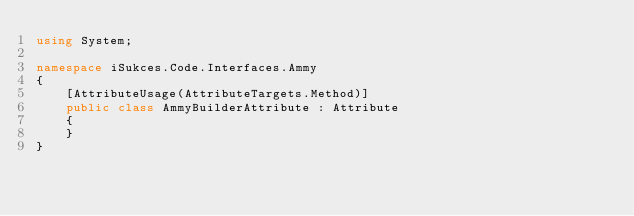Convert code to text. <code><loc_0><loc_0><loc_500><loc_500><_C#_>using System;

namespace iSukces.Code.Interfaces.Ammy
{
    [AttributeUsage(AttributeTargets.Method)]
    public class AmmyBuilderAttribute : Attribute
    {
    }
}</code> 